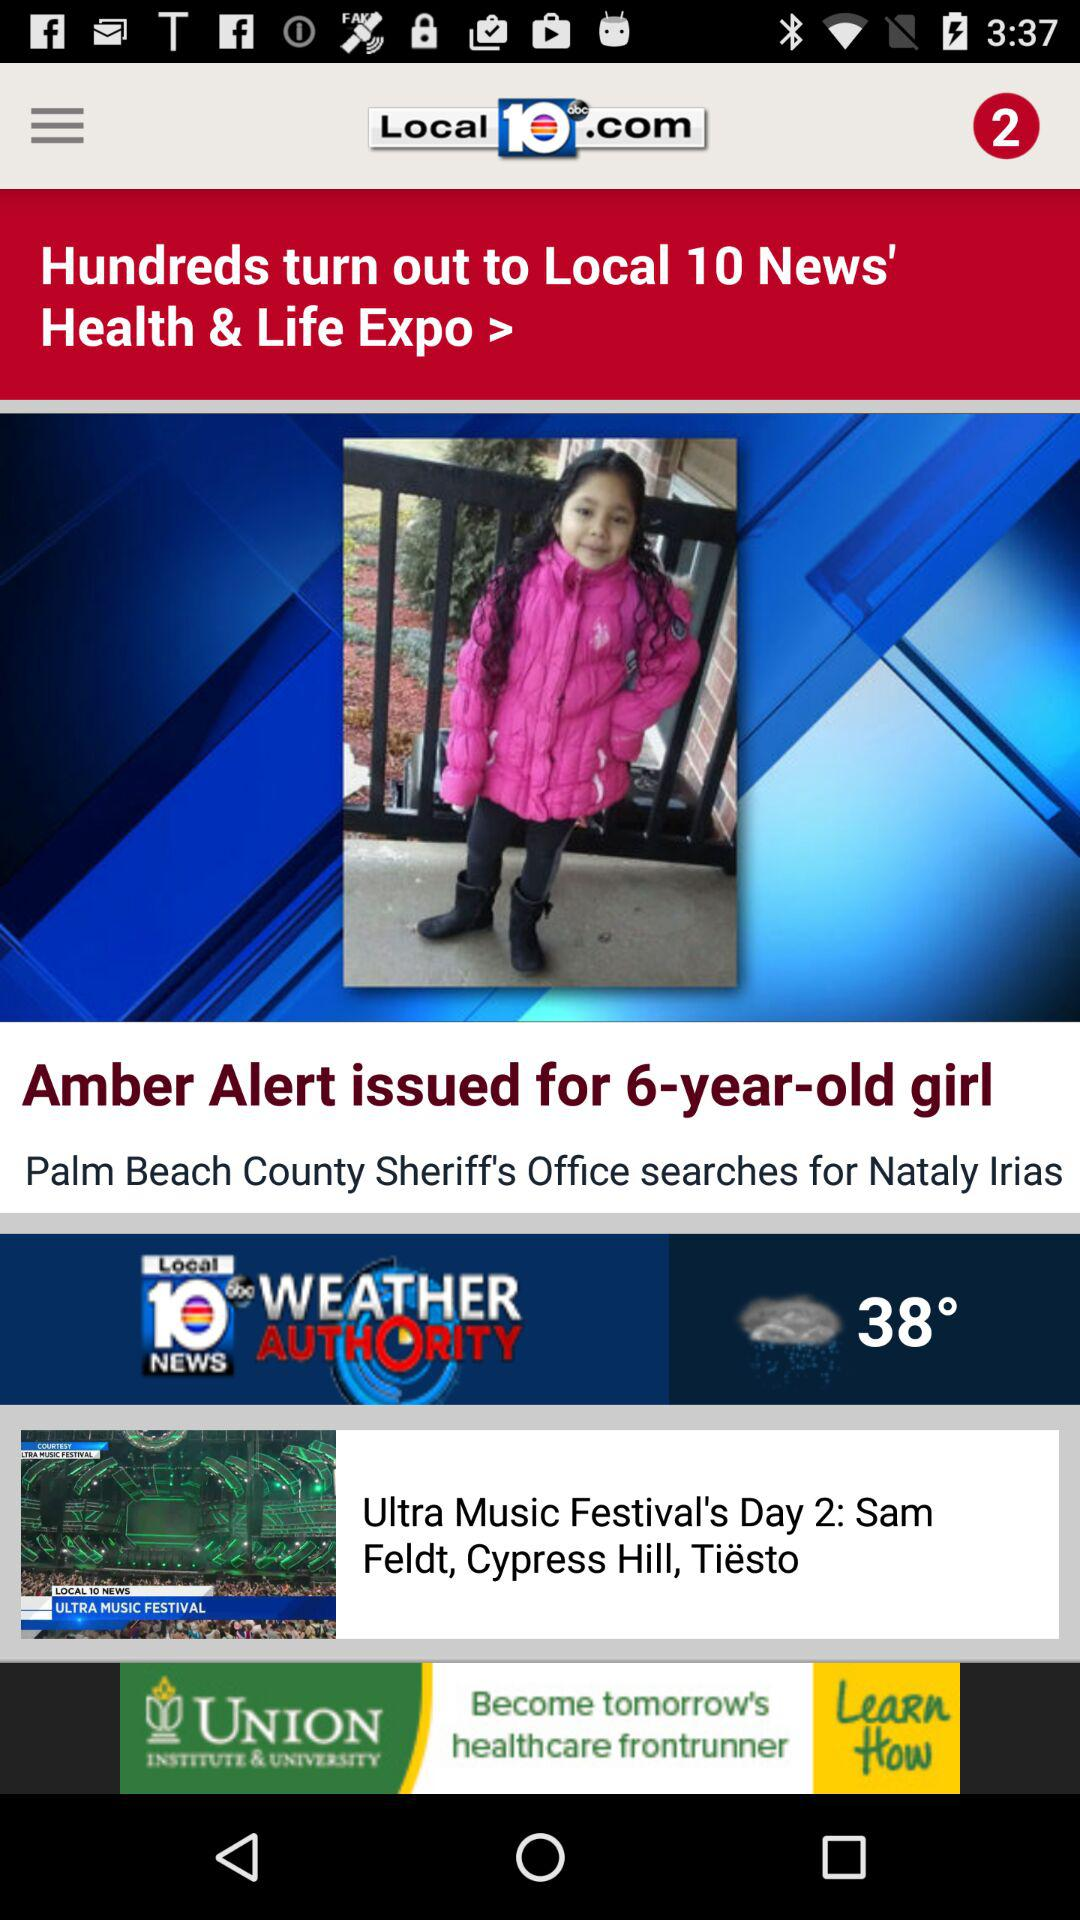What is the application name? The application name is "Local 10 News". 